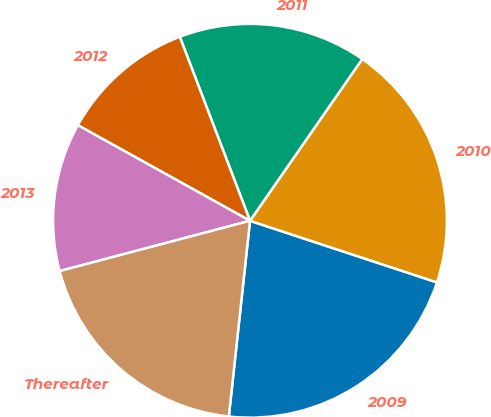<chart> <loc_0><loc_0><loc_500><loc_500><pie_chart><fcel>2009<fcel>2010<fcel>2011<fcel>2012<fcel>2013<fcel>Thereafter<nl><fcel>21.65%<fcel>20.41%<fcel>15.46%<fcel>11.13%<fcel>12.18%<fcel>19.17%<nl></chart> 